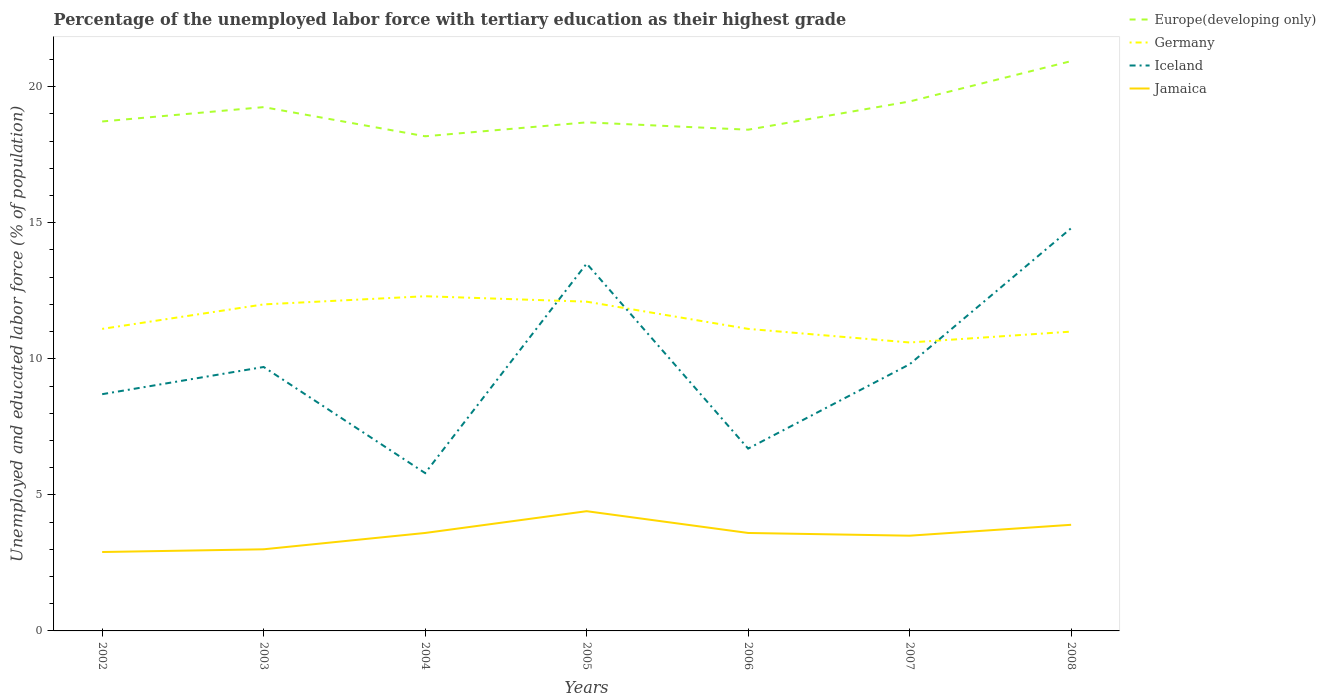How many different coloured lines are there?
Ensure brevity in your answer.  4. Is the number of lines equal to the number of legend labels?
Offer a terse response. Yes. Across all years, what is the maximum percentage of the unemployed labor force with tertiary education in Europe(developing only)?
Ensure brevity in your answer.  18.18. In which year was the percentage of the unemployed labor force with tertiary education in Iceland maximum?
Your response must be concise. 2004. What is the total percentage of the unemployed labor force with tertiary education in Iceland in the graph?
Keep it short and to the point. 2.9. What is the difference between the highest and the second highest percentage of the unemployed labor force with tertiary education in Iceland?
Provide a short and direct response. 9. What is the difference between the highest and the lowest percentage of the unemployed labor force with tertiary education in Iceland?
Give a very brief answer. 2. Is the percentage of the unemployed labor force with tertiary education in Jamaica strictly greater than the percentage of the unemployed labor force with tertiary education in Germany over the years?
Provide a short and direct response. Yes. How many years are there in the graph?
Your response must be concise. 7. Are the values on the major ticks of Y-axis written in scientific E-notation?
Ensure brevity in your answer.  No. Does the graph contain grids?
Provide a succinct answer. No. How are the legend labels stacked?
Offer a very short reply. Vertical. What is the title of the graph?
Provide a succinct answer. Percentage of the unemployed labor force with tertiary education as their highest grade. What is the label or title of the X-axis?
Make the answer very short. Years. What is the label or title of the Y-axis?
Keep it short and to the point. Unemployed and educated labor force (% of population). What is the Unemployed and educated labor force (% of population) of Europe(developing only) in 2002?
Keep it short and to the point. 18.72. What is the Unemployed and educated labor force (% of population) in Germany in 2002?
Give a very brief answer. 11.1. What is the Unemployed and educated labor force (% of population) of Iceland in 2002?
Make the answer very short. 8.7. What is the Unemployed and educated labor force (% of population) of Jamaica in 2002?
Offer a very short reply. 2.9. What is the Unemployed and educated labor force (% of population) in Europe(developing only) in 2003?
Provide a succinct answer. 19.25. What is the Unemployed and educated labor force (% of population) of Germany in 2003?
Your answer should be compact. 12. What is the Unemployed and educated labor force (% of population) in Iceland in 2003?
Your answer should be compact. 9.7. What is the Unemployed and educated labor force (% of population) of Jamaica in 2003?
Give a very brief answer. 3. What is the Unemployed and educated labor force (% of population) in Europe(developing only) in 2004?
Offer a very short reply. 18.18. What is the Unemployed and educated labor force (% of population) of Germany in 2004?
Your response must be concise. 12.3. What is the Unemployed and educated labor force (% of population) of Iceland in 2004?
Provide a short and direct response. 5.8. What is the Unemployed and educated labor force (% of population) of Jamaica in 2004?
Your answer should be very brief. 3.6. What is the Unemployed and educated labor force (% of population) of Europe(developing only) in 2005?
Your response must be concise. 18.69. What is the Unemployed and educated labor force (% of population) in Germany in 2005?
Your answer should be compact. 12.1. What is the Unemployed and educated labor force (% of population) of Iceland in 2005?
Ensure brevity in your answer.  13.5. What is the Unemployed and educated labor force (% of population) of Jamaica in 2005?
Your response must be concise. 4.4. What is the Unemployed and educated labor force (% of population) of Europe(developing only) in 2006?
Provide a short and direct response. 18.42. What is the Unemployed and educated labor force (% of population) in Germany in 2006?
Your answer should be compact. 11.1. What is the Unemployed and educated labor force (% of population) in Iceland in 2006?
Ensure brevity in your answer.  6.7. What is the Unemployed and educated labor force (% of population) in Jamaica in 2006?
Make the answer very short. 3.6. What is the Unemployed and educated labor force (% of population) of Europe(developing only) in 2007?
Offer a terse response. 19.46. What is the Unemployed and educated labor force (% of population) in Germany in 2007?
Keep it short and to the point. 10.6. What is the Unemployed and educated labor force (% of population) of Iceland in 2007?
Offer a terse response. 9.8. What is the Unemployed and educated labor force (% of population) of Europe(developing only) in 2008?
Provide a short and direct response. 20.94. What is the Unemployed and educated labor force (% of population) in Iceland in 2008?
Your answer should be compact. 14.8. What is the Unemployed and educated labor force (% of population) of Jamaica in 2008?
Provide a succinct answer. 3.9. Across all years, what is the maximum Unemployed and educated labor force (% of population) of Europe(developing only)?
Ensure brevity in your answer.  20.94. Across all years, what is the maximum Unemployed and educated labor force (% of population) of Germany?
Keep it short and to the point. 12.3. Across all years, what is the maximum Unemployed and educated labor force (% of population) in Iceland?
Keep it short and to the point. 14.8. Across all years, what is the maximum Unemployed and educated labor force (% of population) in Jamaica?
Give a very brief answer. 4.4. Across all years, what is the minimum Unemployed and educated labor force (% of population) of Europe(developing only)?
Provide a succinct answer. 18.18. Across all years, what is the minimum Unemployed and educated labor force (% of population) in Germany?
Keep it short and to the point. 10.6. Across all years, what is the minimum Unemployed and educated labor force (% of population) of Iceland?
Your answer should be very brief. 5.8. Across all years, what is the minimum Unemployed and educated labor force (% of population) of Jamaica?
Provide a short and direct response. 2.9. What is the total Unemployed and educated labor force (% of population) of Europe(developing only) in the graph?
Make the answer very short. 133.66. What is the total Unemployed and educated labor force (% of population) in Germany in the graph?
Your answer should be compact. 80.2. What is the total Unemployed and educated labor force (% of population) of Iceland in the graph?
Your answer should be compact. 69. What is the total Unemployed and educated labor force (% of population) in Jamaica in the graph?
Your response must be concise. 24.9. What is the difference between the Unemployed and educated labor force (% of population) in Europe(developing only) in 2002 and that in 2003?
Your response must be concise. -0.53. What is the difference between the Unemployed and educated labor force (% of population) in Iceland in 2002 and that in 2003?
Give a very brief answer. -1. What is the difference between the Unemployed and educated labor force (% of population) in Europe(developing only) in 2002 and that in 2004?
Your response must be concise. 0.54. What is the difference between the Unemployed and educated labor force (% of population) in Germany in 2002 and that in 2004?
Offer a terse response. -1.2. What is the difference between the Unemployed and educated labor force (% of population) in Iceland in 2002 and that in 2004?
Offer a terse response. 2.9. What is the difference between the Unemployed and educated labor force (% of population) of Jamaica in 2002 and that in 2004?
Keep it short and to the point. -0.7. What is the difference between the Unemployed and educated labor force (% of population) of Europe(developing only) in 2002 and that in 2005?
Provide a succinct answer. 0.03. What is the difference between the Unemployed and educated labor force (% of population) of Germany in 2002 and that in 2005?
Your response must be concise. -1. What is the difference between the Unemployed and educated labor force (% of population) of Iceland in 2002 and that in 2005?
Make the answer very short. -4.8. What is the difference between the Unemployed and educated labor force (% of population) of Europe(developing only) in 2002 and that in 2006?
Give a very brief answer. 0.3. What is the difference between the Unemployed and educated labor force (% of population) of Germany in 2002 and that in 2006?
Make the answer very short. 0. What is the difference between the Unemployed and educated labor force (% of population) of Jamaica in 2002 and that in 2006?
Your answer should be compact. -0.7. What is the difference between the Unemployed and educated labor force (% of population) of Europe(developing only) in 2002 and that in 2007?
Offer a terse response. -0.73. What is the difference between the Unemployed and educated labor force (% of population) in Iceland in 2002 and that in 2007?
Your answer should be compact. -1.1. What is the difference between the Unemployed and educated labor force (% of population) in Jamaica in 2002 and that in 2007?
Provide a succinct answer. -0.6. What is the difference between the Unemployed and educated labor force (% of population) of Europe(developing only) in 2002 and that in 2008?
Your response must be concise. -2.22. What is the difference between the Unemployed and educated labor force (% of population) of Germany in 2002 and that in 2008?
Your response must be concise. 0.1. What is the difference between the Unemployed and educated labor force (% of population) in Jamaica in 2002 and that in 2008?
Your response must be concise. -1. What is the difference between the Unemployed and educated labor force (% of population) in Europe(developing only) in 2003 and that in 2004?
Provide a succinct answer. 1.07. What is the difference between the Unemployed and educated labor force (% of population) of Europe(developing only) in 2003 and that in 2005?
Provide a succinct answer. 0.56. What is the difference between the Unemployed and educated labor force (% of population) in Iceland in 2003 and that in 2005?
Provide a short and direct response. -3.8. What is the difference between the Unemployed and educated labor force (% of population) in Jamaica in 2003 and that in 2005?
Provide a short and direct response. -1.4. What is the difference between the Unemployed and educated labor force (% of population) of Europe(developing only) in 2003 and that in 2006?
Provide a succinct answer. 0.83. What is the difference between the Unemployed and educated labor force (% of population) in Jamaica in 2003 and that in 2006?
Make the answer very short. -0.6. What is the difference between the Unemployed and educated labor force (% of population) of Europe(developing only) in 2003 and that in 2007?
Your answer should be very brief. -0.21. What is the difference between the Unemployed and educated labor force (% of population) in Iceland in 2003 and that in 2007?
Your answer should be compact. -0.1. What is the difference between the Unemployed and educated labor force (% of population) of Europe(developing only) in 2003 and that in 2008?
Your answer should be very brief. -1.69. What is the difference between the Unemployed and educated labor force (% of population) of Europe(developing only) in 2004 and that in 2005?
Provide a short and direct response. -0.51. What is the difference between the Unemployed and educated labor force (% of population) in Jamaica in 2004 and that in 2005?
Make the answer very short. -0.8. What is the difference between the Unemployed and educated labor force (% of population) in Europe(developing only) in 2004 and that in 2006?
Keep it short and to the point. -0.24. What is the difference between the Unemployed and educated labor force (% of population) of Germany in 2004 and that in 2006?
Offer a terse response. 1.2. What is the difference between the Unemployed and educated labor force (% of population) of Jamaica in 2004 and that in 2006?
Ensure brevity in your answer.  0. What is the difference between the Unemployed and educated labor force (% of population) of Europe(developing only) in 2004 and that in 2007?
Offer a terse response. -1.28. What is the difference between the Unemployed and educated labor force (% of population) in Germany in 2004 and that in 2007?
Provide a short and direct response. 1.7. What is the difference between the Unemployed and educated labor force (% of population) in Iceland in 2004 and that in 2007?
Offer a terse response. -4. What is the difference between the Unemployed and educated labor force (% of population) in Europe(developing only) in 2004 and that in 2008?
Give a very brief answer. -2.76. What is the difference between the Unemployed and educated labor force (% of population) in Iceland in 2004 and that in 2008?
Provide a short and direct response. -9. What is the difference between the Unemployed and educated labor force (% of population) in Europe(developing only) in 2005 and that in 2006?
Make the answer very short. 0.27. What is the difference between the Unemployed and educated labor force (% of population) in Jamaica in 2005 and that in 2006?
Your answer should be compact. 0.8. What is the difference between the Unemployed and educated labor force (% of population) in Europe(developing only) in 2005 and that in 2007?
Ensure brevity in your answer.  -0.77. What is the difference between the Unemployed and educated labor force (% of population) of Iceland in 2005 and that in 2007?
Offer a terse response. 3.7. What is the difference between the Unemployed and educated labor force (% of population) in Jamaica in 2005 and that in 2007?
Your answer should be compact. 0.9. What is the difference between the Unemployed and educated labor force (% of population) of Europe(developing only) in 2005 and that in 2008?
Your answer should be very brief. -2.25. What is the difference between the Unemployed and educated labor force (% of population) of Iceland in 2005 and that in 2008?
Offer a terse response. -1.3. What is the difference between the Unemployed and educated labor force (% of population) in Jamaica in 2005 and that in 2008?
Provide a succinct answer. 0.5. What is the difference between the Unemployed and educated labor force (% of population) of Europe(developing only) in 2006 and that in 2007?
Make the answer very short. -1.04. What is the difference between the Unemployed and educated labor force (% of population) in Germany in 2006 and that in 2007?
Provide a succinct answer. 0.5. What is the difference between the Unemployed and educated labor force (% of population) of Europe(developing only) in 2006 and that in 2008?
Your answer should be very brief. -2.52. What is the difference between the Unemployed and educated labor force (% of population) of Germany in 2006 and that in 2008?
Offer a very short reply. 0.1. What is the difference between the Unemployed and educated labor force (% of population) of Europe(developing only) in 2007 and that in 2008?
Offer a very short reply. -1.48. What is the difference between the Unemployed and educated labor force (% of population) of Iceland in 2007 and that in 2008?
Provide a short and direct response. -5. What is the difference between the Unemployed and educated labor force (% of population) of Europe(developing only) in 2002 and the Unemployed and educated labor force (% of population) of Germany in 2003?
Give a very brief answer. 6.72. What is the difference between the Unemployed and educated labor force (% of population) in Europe(developing only) in 2002 and the Unemployed and educated labor force (% of population) in Iceland in 2003?
Ensure brevity in your answer.  9.02. What is the difference between the Unemployed and educated labor force (% of population) in Europe(developing only) in 2002 and the Unemployed and educated labor force (% of population) in Jamaica in 2003?
Offer a terse response. 15.72. What is the difference between the Unemployed and educated labor force (% of population) of Germany in 2002 and the Unemployed and educated labor force (% of population) of Iceland in 2003?
Give a very brief answer. 1.4. What is the difference between the Unemployed and educated labor force (% of population) in Europe(developing only) in 2002 and the Unemployed and educated labor force (% of population) in Germany in 2004?
Offer a very short reply. 6.42. What is the difference between the Unemployed and educated labor force (% of population) of Europe(developing only) in 2002 and the Unemployed and educated labor force (% of population) of Iceland in 2004?
Ensure brevity in your answer.  12.92. What is the difference between the Unemployed and educated labor force (% of population) of Europe(developing only) in 2002 and the Unemployed and educated labor force (% of population) of Jamaica in 2004?
Give a very brief answer. 15.12. What is the difference between the Unemployed and educated labor force (% of population) in Germany in 2002 and the Unemployed and educated labor force (% of population) in Iceland in 2004?
Ensure brevity in your answer.  5.3. What is the difference between the Unemployed and educated labor force (% of population) of Germany in 2002 and the Unemployed and educated labor force (% of population) of Jamaica in 2004?
Provide a short and direct response. 7.5. What is the difference between the Unemployed and educated labor force (% of population) in Europe(developing only) in 2002 and the Unemployed and educated labor force (% of population) in Germany in 2005?
Ensure brevity in your answer.  6.62. What is the difference between the Unemployed and educated labor force (% of population) in Europe(developing only) in 2002 and the Unemployed and educated labor force (% of population) in Iceland in 2005?
Offer a very short reply. 5.22. What is the difference between the Unemployed and educated labor force (% of population) in Europe(developing only) in 2002 and the Unemployed and educated labor force (% of population) in Jamaica in 2005?
Ensure brevity in your answer.  14.32. What is the difference between the Unemployed and educated labor force (% of population) in Europe(developing only) in 2002 and the Unemployed and educated labor force (% of population) in Germany in 2006?
Your answer should be compact. 7.62. What is the difference between the Unemployed and educated labor force (% of population) of Europe(developing only) in 2002 and the Unemployed and educated labor force (% of population) of Iceland in 2006?
Offer a terse response. 12.02. What is the difference between the Unemployed and educated labor force (% of population) of Europe(developing only) in 2002 and the Unemployed and educated labor force (% of population) of Jamaica in 2006?
Your answer should be compact. 15.12. What is the difference between the Unemployed and educated labor force (% of population) in Germany in 2002 and the Unemployed and educated labor force (% of population) in Iceland in 2006?
Offer a terse response. 4.4. What is the difference between the Unemployed and educated labor force (% of population) in Europe(developing only) in 2002 and the Unemployed and educated labor force (% of population) in Germany in 2007?
Ensure brevity in your answer.  8.12. What is the difference between the Unemployed and educated labor force (% of population) of Europe(developing only) in 2002 and the Unemployed and educated labor force (% of population) of Iceland in 2007?
Your response must be concise. 8.92. What is the difference between the Unemployed and educated labor force (% of population) in Europe(developing only) in 2002 and the Unemployed and educated labor force (% of population) in Jamaica in 2007?
Give a very brief answer. 15.22. What is the difference between the Unemployed and educated labor force (% of population) of Europe(developing only) in 2002 and the Unemployed and educated labor force (% of population) of Germany in 2008?
Offer a terse response. 7.72. What is the difference between the Unemployed and educated labor force (% of population) of Europe(developing only) in 2002 and the Unemployed and educated labor force (% of population) of Iceland in 2008?
Offer a terse response. 3.92. What is the difference between the Unemployed and educated labor force (% of population) in Europe(developing only) in 2002 and the Unemployed and educated labor force (% of population) in Jamaica in 2008?
Offer a very short reply. 14.82. What is the difference between the Unemployed and educated labor force (% of population) of Europe(developing only) in 2003 and the Unemployed and educated labor force (% of population) of Germany in 2004?
Your answer should be very brief. 6.95. What is the difference between the Unemployed and educated labor force (% of population) of Europe(developing only) in 2003 and the Unemployed and educated labor force (% of population) of Iceland in 2004?
Provide a succinct answer. 13.45. What is the difference between the Unemployed and educated labor force (% of population) of Europe(developing only) in 2003 and the Unemployed and educated labor force (% of population) of Jamaica in 2004?
Ensure brevity in your answer.  15.65. What is the difference between the Unemployed and educated labor force (% of population) of Europe(developing only) in 2003 and the Unemployed and educated labor force (% of population) of Germany in 2005?
Your answer should be very brief. 7.15. What is the difference between the Unemployed and educated labor force (% of population) in Europe(developing only) in 2003 and the Unemployed and educated labor force (% of population) in Iceland in 2005?
Make the answer very short. 5.75. What is the difference between the Unemployed and educated labor force (% of population) in Europe(developing only) in 2003 and the Unemployed and educated labor force (% of population) in Jamaica in 2005?
Make the answer very short. 14.85. What is the difference between the Unemployed and educated labor force (% of population) in Germany in 2003 and the Unemployed and educated labor force (% of population) in Iceland in 2005?
Make the answer very short. -1.5. What is the difference between the Unemployed and educated labor force (% of population) of Iceland in 2003 and the Unemployed and educated labor force (% of population) of Jamaica in 2005?
Your response must be concise. 5.3. What is the difference between the Unemployed and educated labor force (% of population) in Europe(developing only) in 2003 and the Unemployed and educated labor force (% of population) in Germany in 2006?
Ensure brevity in your answer.  8.15. What is the difference between the Unemployed and educated labor force (% of population) in Europe(developing only) in 2003 and the Unemployed and educated labor force (% of population) in Iceland in 2006?
Provide a succinct answer. 12.55. What is the difference between the Unemployed and educated labor force (% of population) in Europe(developing only) in 2003 and the Unemployed and educated labor force (% of population) in Jamaica in 2006?
Ensure brevity in your answer.  15.65. What is the difference between the Unemployed and educated labor force (% of population) of Iceland in 2003 and the Unemployed and educated labor force (% of population) of Jamaica in 2006?
Provide a short and direct response. 6.1. What is the difference between the Unemployed and educated labor force (% of population) in Europe(developing only) in 2003 and the Unemployed and educated labor force (% of population) in Germany in 2007?
Offer a very short reply. 8.65. What is the difference between the Unemployed and educated labor force (% of population) in Europe(developing only) in 2003 and the Unemployed and educated labor force (% of population) in Iceland in 2007?
Offer a very short reply. 9.45. What is the difference between the Unemployed and educated labor force (% of population) of Europe(developing only) in 2003 and the Unemployed and educated labor force (% of population) of Jamaica in 2007?
Offer a very short reply. 15.75. What is the difference between the Unemployed and educated labor force (% of population) in Germany in 2003 and the Unemployed and educated labor force (% of population) in Iceland in 2007?
Ensure brevity in your answer.  2.2. What is the difference between the Unemployed and educated labor force (% of population) in Germany in 2003 and the Unemployed and educated labor force (% of population) in Jamaica in 2007?
Ensure brevity in your answer.  8.5. What is the difference between the Unemployed and educated labor force (% of population) of Europe(developing only) in 2003 and the Unemployed and educated labor force (% of population) of Germany in 2008?
Give a very brief answer. 8.25. What is the difference between the Unemployed and educated labor force (% of population) in Europe(developing only) in 2003 and the Unemployed and educated labor force (% of population) in Iceland in 2008?
Your answer should be very brief. 4.45. What is the difference between the Unemployed and educated labor force (% of population) of Europe(developing only) in 2003 and the Unemployed and educated labor force (% of population) of Jamaica in 2008?
Keep it short and to the point. 15.35. What is the difference between the Unemployed and educated labor force (% of population) of Germany in 2003 and the Unemployed and educated labor force (% of population) of Jamaica in 2008?
Provide a succinct answer. 8.1. What is the difference between the Unemployed and educated labor force (% of population) of Iceland in 2003 and the Unemployed and educated labor force (% of population) of Jamaica in 2008?
Provide a short and direct response. 5.8. What is the difference between the Unemployed and educated labor force (% of population) of Europe(developing only) in 2004 and the Unemployed and educated labor force (% of population) of Germany in 2005?
Give a very brief answer. 6.08. What is the difference between the Unemployed and educated labor force (% of population) of Europe(developing only) in 2004 and the Unemployed and educated labor force (% of population) of Iceland in 2005?
Your answer should be compact. 4.68. What is the difference between the Unemployed and educated labor force (% of population) of Europe(developing only) in 2004 and the Unemployed and educated labor force (% of population) of Jamaica in 2005?
Offer a very short reply. 13.78. What is the difference between the Unemployed and educated labor force (% of population) of Germany in 2004 and the Unemployed and educated labor force (% of population) of Jamaica in 2005?
Give a very brief answer. 7.9. What is the difference between the Unemployed and educated labor force (% of population) in Iceland in 2004 and the Unemployed and educated labor force (% of population) in Jamaica in 2005?
Keep it short and to the point. 1.4. What is the difference between the Unemployed and educated labor force (% of population) in Europe(developing only) in 2004 and the Unemployed and educated labor force (% of population) in Germany in 2006?
Give a very brief answer. 7.08. What is the difference between the Unemployed and educated labor force (% of population) in Europe(developing only) in 2004 and the Unemployed and educated labor force (% of population) in Iceland in 2006?
Ensure brevity in your answer.  11.48. What is the difference between the Unemployed and educated labor force (% of population) of Europe(developing only) in 2004 and the Unemployed and educated labor force (% of population) of Jamaica in 2006?
Offer a terse response. 14.58. What is the difference between the Unemployed and educated labor force (% of population) of Germany in 2004 and the Unemployed and educated labor force (% of population) of Iceland in 2006?
Make the answer very short. 5.6. What is the difference between the Unemployed and educated labor force (% of population) of Europe(developing only) in 2004 and the Unemployed and educated labor force (% of population) of Germany in 2007?
Offer a very short reply. 7.58. What is the difference between the Unemployed and educated labor force (% of population) in Europe(developing only) in 2004 and the Unemployed and educated labor force (% of population) in Iceland in 2007?
Make the answer very short. 8.38. What is the difference between the Unemployed and educated labor force (% of population) in Europe(developing only) in 2004 and the Unemployed and educated labor force (% of population) in Jamaica in 2007?
Your answer should be compact. 14.68. What is the difference between the Unemployed and educated labor force (% of population) in Germany in 2004 and the Unemployed and educated labor force (% of population) in Iceland in 2007?
Your answer should be compact. 2.5. What is the difference between the Unemployed and educated labor force (% of population) of Europe(developing only) in 2004 and the Unemployed and educated labor force (% of population) of Germany in 2008?
Give a very brief answer. 7.18. What is the difference between the Unemployed and educated labor force (% of population) of Europe(developing only) in 2004 and the Unemployed and educated labor force (% of population) of Iceland in 2008?
Provide a short and direct response. 3.38. What is the difference between the Unemployed and educated labor force (% of population) in Europe(developing only) in 2004 and the Unemployed and educated labor force (% of population) in Jamaica in 2008?
Your answer should be compact. 14.28. What is the difference between the Unemployed and educated labor force (% of population) in Germany in 2004 and the Unemployed and educated labor force (% of population) in Iceland in 2008?
Provide a succinct answer. -2.5. What is the difference between the Unemployed and educated labor force (% of population) in Iceland in 2004 and the Unemployed and educated labor force (% of population) in Jamaica in 2008?
Provide a short and direct response. 1.9. What is the difference between the Unemployed and educated labor force (% of population) in Europe(developing only) in 2005 and the Unemployed and educated labor force (% of population) in Germany in 2006?
Offer a very short reply. 7.59. What is the difference between the Unemployed and educated labor force (% of population) of Europe(developing only) in 2005 and the Unemployed and educated labor force (% of population) of Iceland in 2006?
Keep it short and to the point. 11.99. What is the difference between the Unemployed and educated labor force (% of population) in Europe(developing only) in 2005 and the Unemployed and educated labor force (% of population) in Jamaica in 2006?
Offer a very short reply. 15.09. What is the difference between the Unemployed and educated labor force (% of population) in Germany in 2005 and the Unemployed and educated labor force (% of population) in Iceland in 2006?
Provide a short and direct response. 5.4. What is the difference between the Unemployed and educated labor force (% of population) in Europe(developing only) in 2005 and the Unemployed and educated labor force (% of population) in Germany in 2007?
Ensure brevity in your answer.  8.09. What is the difference between the Unemployed and educated labor force (% of population) in Europe(developing only) in 2005 and the Unemployed and educated labor force (% of population) in Iceland in 2007?
Make the answer very short. 8.89. What is the difference between the Unemployed and educated labor force (% of population) of Europe(developing only) in 2005 and the Unemployed and educated labor force (% of population) of Jamaica in 2007?
Provide a succinct answer. 15.19. What is the difference between the Unemployed and educated labor force (% of population) in Europe(developing only) in 2005 and the Unemployed and educated labor force (% of population) in Germany in 2008?
Your answer should be compact. 7.69. What is the difference between the Unemployed and educated labor force (% of population) of Europe(developing only) in 2005 and the Unemployed and educated labor force (% of population) of Iceland in 2008?
Your answer should be compact. 3.89. What is the difference between the Unemployed and educated labor force (% of population) in Europe(developing only) in 2005 and the Unemployed and educated labor force (% of population) in Jamaica in 2008?
Provide a short and direct response. 14.79. What is the difference between the Unemployed and educated labor force (% of population) in Germany in 2005 and the Unemployed and educated labor force (% of population) in Iceland in 2008?
Provide a succinct answer. -2.7. What is the difference between the Unemployed and educated labor force (% of population) of Germany in 2005 and the Unemployed and educated labor force (% of population) of Jamaica in 2008?
Offer a terse response. 8.2. What is the difference between the Unemployed and educated labor force (% of population) in Iceland in 2005 and the Unemployed and educated labor force (% of population) in Jamaica in 2008?
Keep it short and to the point. 9.6. What is the difference between the Unemployed and educated labor force (% of population) in Europe(developing only) in 2006 and the Unemployed and educated labor force (% of population) in Germany in 2007?
Give a very brief answer. 7.82. What is the difference between the Unemployed and educated labor force (% of population) of Europe(developing only) in 2006 and the Unemployed and educated labor force (% of population) of Iceland in 2007?
Give a very brief answer. 8.62. What is the difference between the Unemployed and educated labor force (% of population) in Europe(developing only) in 2006 and the Unemployed and educated labor force (% of population) in Jamaica in 2007?
Offer a terse response. 14.92. What is the difference between the Unemployed and educated labor force (% of population) in Germany in 2006 and the Unemployed and educated labor force (% of population) in Jamaica in 2007?
Your response must be concise. 7.6. What is the difference between the Unemployed and educated labor force (% of population) in Iceland in 2006 and the Unemployed and educated labor force (% of population) in Jamaica in 2007?
Your response must be concise. 3.2. What is the difference between the Unemployed and educated labor force (% of population) in Europe(developing only) in 2006 and the Unemployed and educated labor force (% of population) in Germany in 2008?
Your answer should be very brief. 7.42. What is the difference between the Unemployed and educated labor force (% of population) of Europe(developing only) in 2006 and the Unemployed and educated labor force (% of population) of Iceland in 2008?
Your answer should be compact. 3.62. What is the difference between the Unemployed and educated labor force (% of population) of Europe(developing only) in 2006 and the Unemployed and educated labor force (% of population) of Jamaica in 2008?
Give a very brief answer. 14.52. What is the difference between the Unemployed and educated labor force (% of population) of Germany in 2006 and the Unemployed and educated labor force (% of population) of Iceland in 2008?
Keep it short and to the point. -3.7. What is the difference between the Unemployed and educated labor force (% of population) of Iceland in 2006 and the Unemployed and educated labor force (% of population) of Jamaica in 2008?
Provide a short and direct response. 2.8. What is the difference between the Unemployed and educated labor force (% of population) of Europe(developing only) in 2007 and the Unemployed and educated labor force (% of population) of Germany in 2008?
Offer a very short reply. 8.46. What is the difference between the Unemployed and educated labor force (% of population) in Europe(developing only) in 2007 and the Unemployed and educated labor force (% of population) in Iceland in 2008?
Your response must be concise. 4.66. What is the difference between the Unemployed and educated labor force (% of population) in Europe(developing only) in 2007 and the Unemployed and educated labor force (% of population) in Jamaica in 2008?
Your response must be concise. 15.56. What is the difference between the Unemployed and educated labor force (% of population) of Germany in 2007 and the Unemployed and educated labor force (% of population) of Iceland in 2008?
Your answer should be very brief. -4.2. What is the difference between the Unemployed and educated labor force (% of population) of Germany in 2007 and the Unemployed and educated labor force (% of population) of Jamaica in 2008?
Provide a succinct answer. 6.7. What is the average Unemployed and educated labor force (% of population) in Europe(developing only) per year?
Your response must be concise. 19.09. What is the average Unemployed and educated labor force (% of population) of Germany per year?
Provide a succinct answer. 11.46. What is the average Unemployed and educated labor force (% of population) in Iceland per year?
Provide a short and direct response. 9.86. What is the average Unemployed and educated labor force (% of population) of Jamaica per year?
Offer a very short reply. 3.56. In the year 2002, what is the difference between the Unemployed and educated labor force (% of population) in Europe(developing only) and Unemployed and educated labor force (% of population) in Germany?
Your response must be concise. 7.62. In the year 2002, what is the difference between the Unemployed and educated labor force (% of population) in Europe(developing only) and Unemployed and educated labor force (% of population) in Iceland?
Your answer should be very brief. 10.02. In the year 2002, what is the difference between the Unemployed and educated labor force (% of population) in Europe(developing only) and Unemployed and educated labor force (% of population) in Jamaica?
Your answer should be compact. 15.82. In the year 2003, what is the difference between the Unemployed and educated labor force (% of population) in Europe(developing only) and Unemployed and educated labor force (% of population) in Germany?
Provide a succinct answer. 7.25. In the year 2003, what is the difference between the Unemployed and educated labor force (% of population) in Europe(developing only) and Unemployed and educated labor force (% of population) in Iceland?
Give a very brief answer. 9.55. In the year 2003, what is the difference between the Unemployed and educated labor force (% of population) in Europe(developing only) and Unemployed and educated labor force (% of population) in Jamaica?
Provide a succinct answer. 16.25. In the year 2003, what is the difference between the Unemployed and educated labor force (% of population) in Iceland and Unemployed and educated labor force (% of population) in Jamaica?
Provide a succinct answer. 6.7. In the year 2004, what is the difference between the Unemployed and educated labor force (% of population) in Europe(developing only) and Unemployed and educated labor force (% of population) in Germany?
Offer a very short reply. 5.88. In the year 2004, what is the difference between the Unemployed and educated labor force (% of population) in Europe(developing only) and Unemployed and educated labor force (% of population) in Iceland?
Give a very brief answer. 12.38. In the year 2004, what is the difference between the Unemployed and educated labor force (% of population) in Europe(developing only) and Unemployed and educated labor force (% of population) in Jamaica?
Your answer should be compact. 14.58. In the year 2004, what is the difference between the Unemployed and educated labor force (% of population) in Germany and Unemployed and educated labor force (% of population) in Jamaica?
Your answer should be very brief. 8.7. In the year 2005, what is the difference between the Unemployed and educated labor force (% of population) of Europe(developing only) and Unemployed and educated labor force (% of population) of Germany?
Your answer should be very brief. 6.59. In the year 2005, what is the difference between the Unemployed and educated labor force (% of population) of Europe(developing only) and Unemployed and educated labor force (% of population) of Iceland?
Your answer should be compact. 5.19. In the year 2005, what is the difference between the Unemployed and educated labor force (% of population) of Europe(developing only) and Unemployed and educated labor force (% of population) of Jamaica?
Ensure brevity in your answer.  14.29. In the year 2005, what is the difference between the Unemployed and educated labor force (% of population) in Germany and Unemployed and educated labor force (% of population) in Iceland?
Offer a terse response. -1.4. In the year 2006, what is the difference between the Unemployed and educated labor force (% of population) in Europe(developing only) and Unemployed and educated labor force (% of population) in Germany?
Give a very brief answer. 7.32. In the year 2006, what is the difference between the Unemployed and educated labor force (% of population) in Europe(developing only) and Unemployed and educated labor force (% of population) in Iceland?
Give a very brief answer. 11.72. In the year 2006, what is the difference between the Unemployed and educated labor force (% of population) of Europe(developing only) and Unemployed and educated labor force (% of population) of Jamaica?
Make the answer very short. 14.82. In the year 2006, what is the difference between the Unemployed and educated labor force (% of population) of Germany and Unemployed and educated labor force (% of population) of Jamaica?
Your response must be concise. 7.5. In the year 2007, what is the difference between the Unemployed and educated labor force (% of population) of Europe(developing only) and Unemployed and educated labor force (% of population) of Germany?
Offer a very short reply. 8.86. In the year 2007, what is the difference between the Unemployed and educated labor force (% of population) of Europe(developing only) and Unemployed and educated labor force (% of population) of Iceland?
Provide a succinct answer. 9.66. In the year 2007, what is the difference between the Unemployed and educated labor force (% of population) of Europe(developing only) and Unemployed and educated labor force (% of population) of Jamaica?
Provide a short and direct response. 15.96. In the year 2007, what is the difference between the Unemployed and educated labor force (% of population) of Germany and Unemployed and educated labor force (% of population) of Iceland?
Your response must be concise. 0.8. In the year 2007, what is the difference between the Unemployed and educated labor force (% of population) of Iceland and Unemployed and educated labor force (% of population) of Jamaica?
Provide a succinct answer. 6.3. In the year 2008, what is the difference between the Unemployed and educated labor force (% of population) of Europe(developing only) and Unemployed and educated labor force (% of population) of Germany?
Your answer should be very brief. 9.94. In the year 2008, what is the difference between the Unemployed and educated labor force (% of population) of Europe(developing only) and Unemployed and educated labor force (% of population) of Iceland?
Ensure brevity in your answer.  6.14. In the year 2008, what is the difference between the Unemployed and educated labor force (% of population) in Europe(developing only) and Unemployed and educated labor force (% of population) in Jamaica?
Your answer should be compact. 17.04. In the year 2008, what is the difference between the Unemployed and educated labor force (% of population) of Germany and Unemployed and educated labor force (% of population) of Jamaica?
Offer a very short reply. 7.1. In the year 2008, what is the difference between the Unemployed and educated labor force (% of population) of Iceland and Unemployed and educated labor force (% of population) of Jamaica?
Provide a short and direct response. 10.9. What is the ratio of the Unemployed and educated labor force (% of population) in Europe(developing only) in 2002 to that in 2003?
Make the answer very short. 0.97. What is the ratio of the Unemployed and educated labor force (% of population) of Germany in 2002 to that in 2003?
Provide a short and direct response. 0.93. What is the ratio of the Unemployed and educated labor force (% of population) of Iceland in 2002 to that in 2003?
Your answer should be compact. 0.9. What is the ratio of the Unemployed and educated labor force (% of population) of Jamaica in 2002 to that in 2003?
Your answer should be compact. 0.97. What is the ratio of the Unemployed and educated labor force (% of population) of Europe(developing only) in 2002 to that in 2004?
Provide a short and direct response. 1.03. What is the ratio of the Unemployed and educated labor force (% of population) in Germany in 2002 to that in 2004?
Your response must be concise. 0.9. What is the ratio of the Unemployed and educated labor force (% of population) in Iceland in 2002 to that in 2004?
Provide a succinct answer. 1.5. What is the ratio of the Unemployed and educated labor force (% of population) in Jamaica in 2002 to that in 2004?
Provide a succinct answer. 0.81. What is the ratio of the Unemployed and educated labor force (% of population) of Europe(developing only) in 2002 to that in 2005?
Make the answer very short. 1. What is the ratio of the Unemployed and educated labor force (% of population) in Germany in 2002 to that in 2005?
Make the answer very short. 0.92. What is the ratio of the Unemployed and educated labor force (% of population) in Iceland in 2002 to that in 2005?
Give a very brief answer. 0.64. What is the ratio of the Unemployed and educated labor force (% of population) in Jamaica in 2002 to that in 2005?
Your answer should be compact. 0.66. What is the ratio of the Unemployed and educated labor force (% of population) of Europe(developing only) in 2002 to that in 2006?
Make the answer very short. 1.02. What is the ratio of the Unemployed and educated labor force (% of population) of Germany in 2002 to that in 2006?
Your answer should be compact. 1. What is the ratio of the Unemployed and educated labor force (% of population) in Iceland in 2002 to that in 2006?
Your response must be concise. 1.3. What is the ratio of the Unemployed and educated labor force (% of population) of Jamaica in 2002 to that in 2006?
Provide a short and direct response. 0.81. What is the ratio of the Unemployed and educated labor force (% of population) in Europe(developing only) in 2002 to that in 2007?
Ensure brevity in your answer.  0.96. What is the ratio of the Unemployed and educated labor force (% of population) of Germany in 2002 to that in 2007?
Your answer should be very brief. 1.05. What is the ratio of the Unemployed and educated labor force (% of population) in Iceland in 2002 to that in 2007?
Make the answer very short. 0.89. What is the ratio of the Unemployed and educated labor force (% of population) of Jamaica in 2002 to that in 2007?
Your response must be concise. 0.83. What is the ratio of the Unemployed and educated labor force (% of population) of Europe(developing only) in 2002 to that in 2008?
Ensure brevity in your answer.  0.89. What is the ratio of the Unemployed and educated labor force (% of population) in Germany in 2002 to that in 2008?
Your answer should be compact. 1.01. What is the ratio of the Unemployed and educated labor force (% of population) of Iceland in 2002 to that in 2008?
Offer a terse response. 0.59. What is the ratio of the Unemployed and educated labor force (% of population) of Jamaica in 2002 to that in 2008?
Your response must be concise. 0.74. What is the ratio of the Unemployed and educated labor force (% of population) in Europe(developing only) in 2003 to that in 2004?
Your answer should be compact. 1.06. What is the ratio of the Unemployed and educated labor force (% of population) in Germany in 2003 to that in 2004?
Provide a short and direct response. 0.98. What is the ratio of the Unemployed and educated labor force (% of population) in Iceland in 2003 to that in 2004?
Your response must be concise. 1.67. What is the ratio of the Unemployed and educated labor force (% of population) of Europe(developing only) in 2003 to that in 2005?
Offer a terse response. 1.03. What is the ratio of the Unemployed and educated labor force (% of population) of Iceland in 2003 to that in 2005?
Your response must be concise. 0.72. What is the ratio of the Unemployed and educated labor force (% of population) of Jamaica in 2003 to that in 2005?
Provide a succinct answer. 0.68. What is the ratio of the Unemployed and educated labor force (% of population) in Europe(developing only) in 2003 to that in 2006?
Your response must be concise. 1.04. What is the ratio of the Unemployed and educated labor force (% of population) in Germany in 2003 to that in 2006?
Your answer should be compact. 1.08. What is the ratio of the Unemployed and educated labor force (% of population) in Iceland in 2003 to that in 2006?
Offer a terse response. 1.45. What is the ratio of the Unemployed and educated labor force (% of population) in Europe(developing only) in 2003 to that in 2007?
Your response must be concise. 0.99. What is the ratio of the Unemployed and educated labor force (% of population) of Germany in 2003 to that in 2007?
Offer a terse response. 1.13. What is the ratio of the Unemployed and educated labor force (% of population) in Europe(developing only) in 2003 to that in 2008?
Give a very brief answer. 0.92. What is the ratio of the Unemployed and educated labor force (% of population) of Iceland in 2003 to that in 2008?
Keep it short and to the point. 0.66. What is the ratio of the Unemployed and educated labor force (% of population) of Jamaica in 2003 to that in 2008?
Make the answer very short. 0.77. What is the ratio of the Unemployed and educated labor force (% of population) of Europe(developing only) in 2004 to that in 2005?
Your answer should be compact. 0.97. What is the ratio of the Unemployed and educated labor force (% of population) of Germany in 2004 to that in 2005?
Your response must be concise. 1.02. What is the ratio of the Unemployed and educated labor force (% of population) of Iceland in 2004 to that in 2005?
Offer a terse response. 0.43. What is the ratio of the Unemployed and educated labor force (% of population) in Jamaica in 2004 to that in 2005?
Offer a terse response. 0.82. What is the ratio of the Unemployed and educated labor force (% of population) of Europe(developing only) in 2004 to that in 2006?
Provide a succinct answer. 0.99. What is the ratio of the Unemployed and educated labor force (% of population) in Germany in 2004 to that in 2006?
Offer a terse response. 1.11. What is the ratio of the Unemployed and educated labor force (% of population) of Iceland in 2004 to that in 2006?
Give a very brief answer. 0.87. What is the ratio of the Unemployed and educated labor force (% of population) of Jamaica in 2004 to that in 2006?
Offer a very short reply. 1. What is the ratio of the Unemployed and educated labor force (% of population) of Europe(developing only) in 2004 to that in 2007?
Offer a terse response. 0.93. What is the ratio of the Unemployed and educated labor force (% of population) of Germany in 2004 to that in 2007?
Ensure brevity in your answer.  1.16. What is the ratio of the Unemployed and educated labor force (% of population) of Iceland in 2004 to that in 2007?
Your response must be concise. 0.59. What is the ratio of the Unemployed and educated labor force (% of population) of Jamaica in 2004 to that in 2007?
Provide a short and direct response. 1.03. What is the ratio of the Unemployed and educated labor force (% of population) in Europe(developing only) in 2004 to that in 2008?
Offer a very short reply. 0.87. What is the ratio of the Unemployed and educated labor force (% of population) in Germany in 2004 to that in 2008?
Give a very brief answer. 1.12. What is the ratio of the Unemployed and educated labor force (% of population) of Iceland in 2004 to that in 2008?
Make the answer very short. 0.39. What is the ratio of the Unemployed and educated labor force (% of population) of Europe(developing only) in 2005 to that in 2006?
Make the answer very short. 1.01. What is the ratio of the Unemployed and educated labor force (% of population) of Germany in 2005 to that in 2006?
Make the answer very short. 1.09. What is the ratio of the Unemployed and educated labor force (% of population) in Iceland in 2005 to that in 2006?
Offer a terse response. 2.01. What is the ratio of the Unemployed and educated labor force (% of population) of Jamaica in 2005 to that in 2006?
Give a very brief answer. 1.22. What is the ratio of the Unemployed and educated labor force (% of population) of Europe(developing only) in 2005 to that in 2007?
Offer a terse response. 0.96. What is the ratio of the Unemployed and educated labor force (% of population) in Germany in 2005 to that in 2007?
Your response must be concise. 1.14. What is the ratio of the Unemployed and educated labor force (% of population) in Iceland in 2005 to that in 2007?
Your answer should be very brief. 1.38. What is the ratio of the Unemployed and educated labor force (% of population) of Jamaica in 2005 to that in 2007?
Ensure brevity in your answer.  1.26. What is the ratio of the Unemployed and educated labor force (% of population) in Europe(developing only) in 2005 to that in 2008?
Make the answer very short. 0.89. What is the ratio of the Unemployed and educated labor force (% of population) of Iceland in 2005 to that in 2008?
Ensure brevity in your answer.  0.91. What is the ratio of the Unemployed and educated labor force (% of population) of Jamaica in 2005 to that in 2008?
Offer a very short reply. 1.13. What is the ratio of the Unemployed and educated labor force (% of population) of Europe(developing only) in 2006 to that in 2007?
Provide a succinct answer. 0.95. What is the ratio of the Unemployed and educated labor force (% of population) of Germany in 2006 to that in 2007?
Your answer should be very brief. 1.05. What is the ratio of the Unemployed and educated labor force (% of population) in Iceland in 2006 to that in 2007?
Offer a terse response. 0.68. What is the ratio of the Unemployed and educated labor force (% of population) in Jamaica in 2006 to that in 2007?
Offer a terse response. 1.03. What is the ratio of the Unemployed and educated labor force (% of population) of Europe(developing only) in 2006 to that in 2008?
Give a very brief answer. 0.88. What is the ratio of the Unemployed and educated labor force (% of population) of Germany in 2006 to that in 2008?
Offer a very short reply. 1.01. What is the ratio of the Unemployed and educated labor force (% of population) in Iceland in 2006 to that in 2008?
Provide a short and direct response. 0.45. What is the ratio of the Unemployed and educated labor force (% of population) of Europe(developing only) in 2007 to that in 2008?
Your answer should be very brief. 0.93. What is the ratio of the Unemployed and educated labor force (% of population) in Germany in 2007 to that in 2008?
Your response must be concise. 0.96. What is the ratio of the Unemployed and educated labor force (% of population) of Iceland in 2007 to that in 2008?
Your answer should be compact. 0.66. What is the ratio of the Unemployed and educated labor force (% of population) of Jamaica in 2007 to that in 2008?
Ensure brevity in your answer.  0.9. What is the difference between the highest and the second highest Unemployed and educated labor force (% of population) in Europe(developing only)?
Make the answer very short. 1.48. What is the difference between the highest and the lowest Unemployed and educated labor force (% of population) in Europe(developing only)?
Ensure brevity in your answer.  2.76. What is the difference between the highest and the lowest Unemployed and educated labor force (% of population) of Germany?
Make the answer very short. 1.7. What is the difference between the highest and the lowest Unemployed and educated labor force (% of population) of Jamaica?
Your response must be concise. 1.5. 